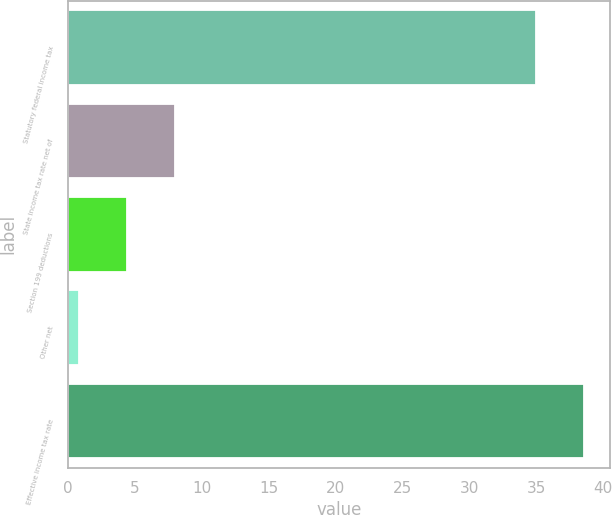Convert chart to OTSL. <chart><loc_0><loc_0><loc_500><loc_500><bar_chart><fcel>Statutory federal income tax<fcel>State income tax rate net of<fcel>Section 199 deductions<fcel>Other net<fcel>Effective income tax rate<nl><fcel>35<fcel>7.98<fcel>4.39<fcel>0.8<fcel>38.59<nl></chart> 